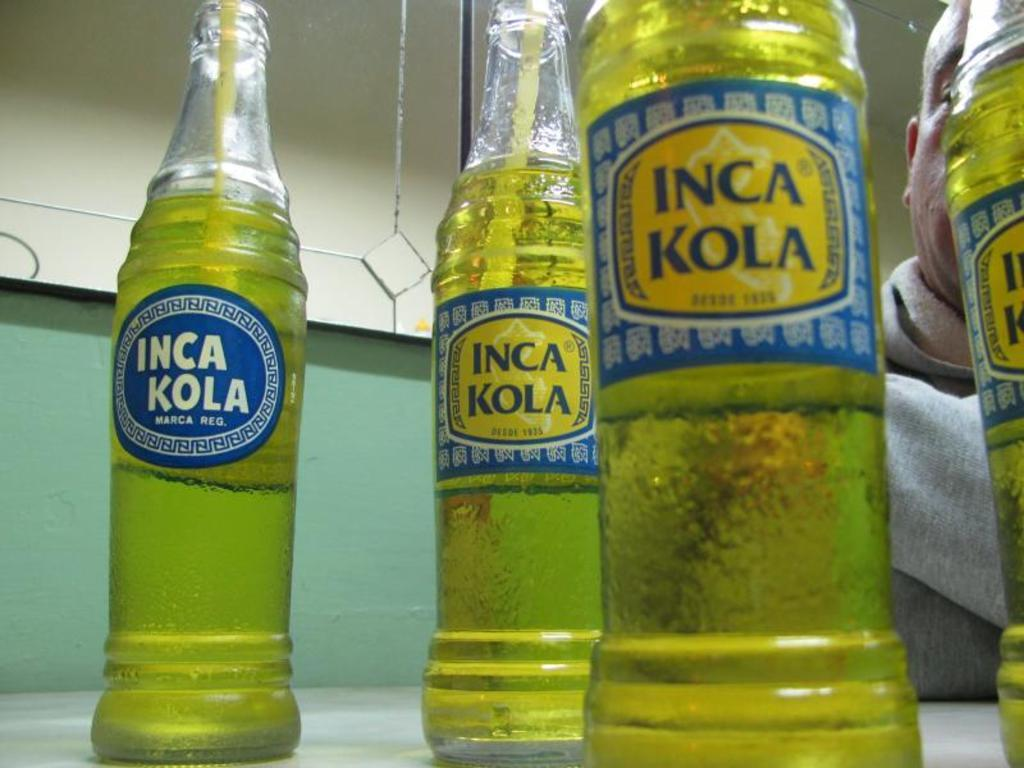<image>
Relay a brief, clear account of the picture shown. Four glass bottles with a green drink in them with INCA KOLA on the front. 